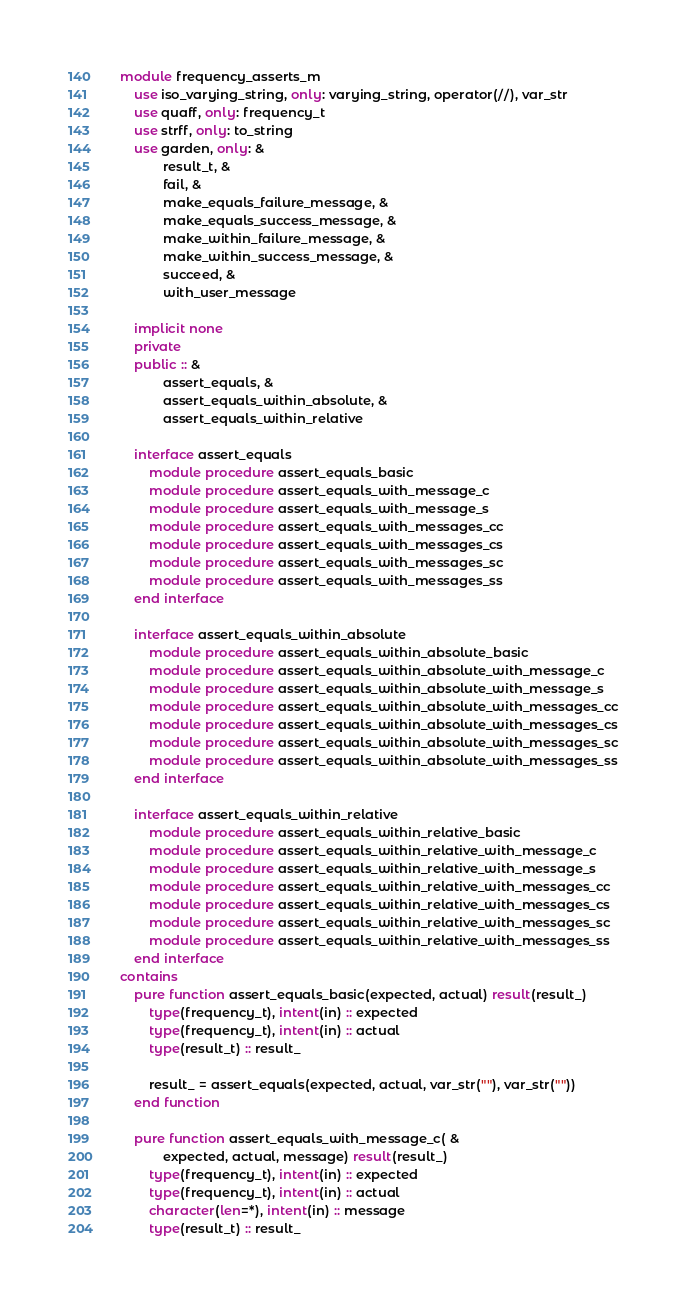<code> <loc_0><loc_0><loc_500><loc_500><_FORTRAN_>module frequency_asserts_m
    use iso_varying_string, only: varying_string, operator(//), var_str
    use quaff, only: frequency_t
    use strff, only: to_string
    use garden, only: &
            result_t, &
            fail, &
            make_equals_failure_message, &
            make_equals_success_message, &
            make_within_failure_message, &
            make_within_success_message, &
            succeed, &
            with_user_message

    implicit none
    private
    public :: &
            assert_equals, &
            assert_equals_within_absolute, &
            assert_equals_within_relative

    interface assert_equals
        module procedure assert_equals_basic
        module procedure assert_equals_with_message_c
        module procedure assert_equals_with_message_s
        module procedure assert_equals_with_messages_cc
        module procedure assert_equals_with_messages_cs
        module procedure assert_equals_with_messages_sc
        module procedure assert_equals_with_messages_ss
    end interface

    interface assert_equals_within_absolute
        module procedure assert_equals_within_absolute_basic
        module procedure assert_equals_within_absolute_with_message_c
        module procedure assert_equals_within_absolute_with_message_s
        module procedure assert_equals_within_absolute_with_messages_cc
        module procedure assert_equals_within_absolute_with_messages_cs
        module procedure assert_equals_within_absolute_with_messages_sc
        module procedure assert_equals_within_absolute_with_messages_ss
    end interface

    interface assert_equals_within_relative
        module procedure assert_equals_within_relative_basic
        module procedure assert_equals_within_relative_with_message_c
        module procedure assert_equals_within_relative_with_message_s
        module procedure assert_equals_within_relative_with_messages_cc
        module procedure assert_equals_within_relative_with_messages_cs
        module procedure assert_equals_within_relative_with_messages_sc
        module procedure assert_equals_within_relative_with_messages_ss
    end interface
contains
    pure function assert_equals_basic(expected, actual) result(result_)
        type(frequency_t), intent(in) :: expected
        type(frequency_t), intent(in) :: actual
        type(result_t) :: result_

        result_ = assert_equals(expected, actual, var_str(""), var_str(""))
    end function

    pure function assert_equals_with_message_c( &
            expected, actual, message) result(result_)
        type(frequency_t), intent(in) :: expected
        type(frequency_t), intent(in) :: actual
        character(len=*), intent(in) :: message
        type(result_t) :: result_
</code> 